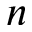Convert formula to latex. <formula><loc_0><loc_0><loc_500><loc_500>n</formula> 